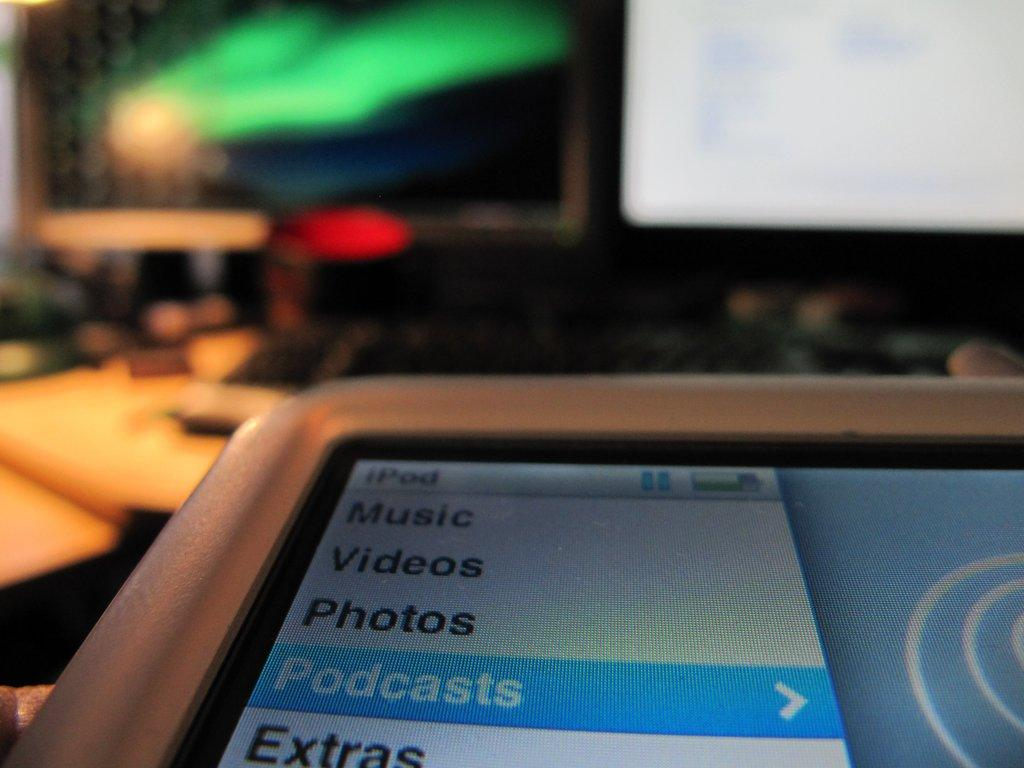<image>
Provide a brief description of the given image. An iPod that is displaying a menu which consists of music, videos, photos, podcasts, and extras. 